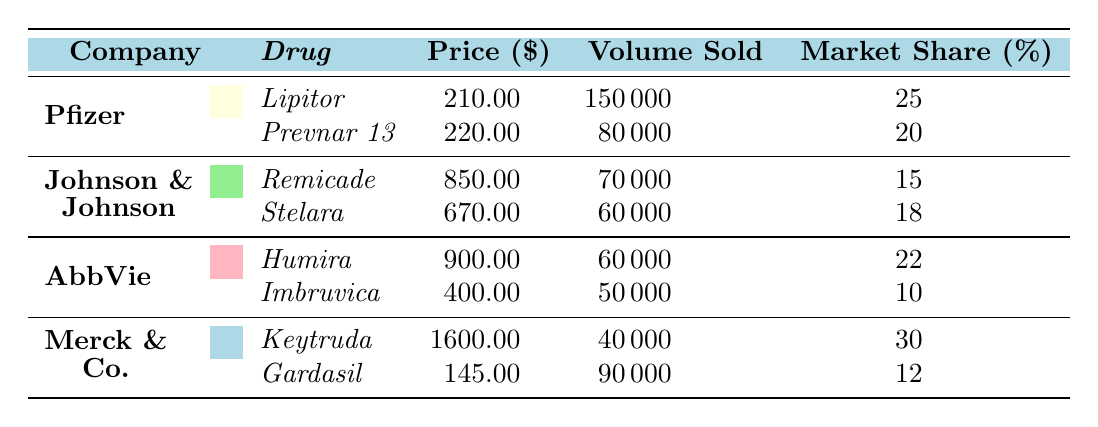What is the price of Remicade? The price of Remicade is found in the second row under the Johnson & Johnson section of the table. It states that Remicade has a price of 850.00.
Answer: 850.00 Which company sells Lipitor? The table indicates that Lipitor is sold by Pfizer, as it is listed under the Pfizer company section.
Answer: Pfizer What is the total volume sold for all drugs by AbbVie? To find the total volume sold for all drugs by AbbVie, we add the volume sold for Humira (60,000) and Imbruvica (50,000): 60,000 + 50,000 = 110,000.
Answer: 110,000 Is the market share of Gardasil greater than or equal to 12%? Looking at the table, Gardasil is listed with a market share of 12%. Since the question asks if its market share is greater than or equal to 12%, the answer is 'yes' because it meets the condition.
Answer: Yes Which drug has the highest price among those listed? By examining the prices of all the drugs in the table, Keytruda at 1,600.00 has the highest price. Other drugs are priced lower: Lipitor (210.00), Prevnar 13 (220.00), Remicade (850.00), Stelara (670.00), Humira (900.00), and Imbruvica (400.00), and Gardasil (145.00).
Answer: 1,600.00 What is the average price of drugs sold by Johnson & Johnson? The average price is calculated by taking the sum of the prices for Remicade (850.00) and Stelara (670.00) and dividing by the number of drugs (2): (850.00 + 670.00) / 2 = 760.00.
Answer: 760.00 Which company's drugs have a combined market share greater than or equal to 60%? To find this, we compute the total market shares: Pfizer (25) + Johnson & Johnson (15 + 18) + AbbVie (22 + 10) + Merck & Co. (30 + 12) = 25 + 33 + 32 + 42 = 132. Since no company alone exceeds 60% when totalized, it's companies combined. Therefore, the answer is that Pfizer, Johnson & Johnson, and AbbVie together exceed this threshold.
Answer: Pfizer, Johnson & Johnson, AbbVie What drug sold the least volume? By reviewing the volume sold for each drug, Keytruda has the lowest volume with 40,000 sold, compared to others: Lipitor (150,000), Prevnar 13 (80,000), Remicade (70,000), Stelara (60,000), Humira (60,000), Imbruvica (50,000), and Gardasil (90,000).
Answer: Keytruda Do all drugs from Merck & Co. have a market share below 15%? Checking the market share of both Keytruda (30) and Gardasil (12), we can see that Keytruda exceeds the 15% threshold. Therefore, the answer is 'no'.
Answer: No 